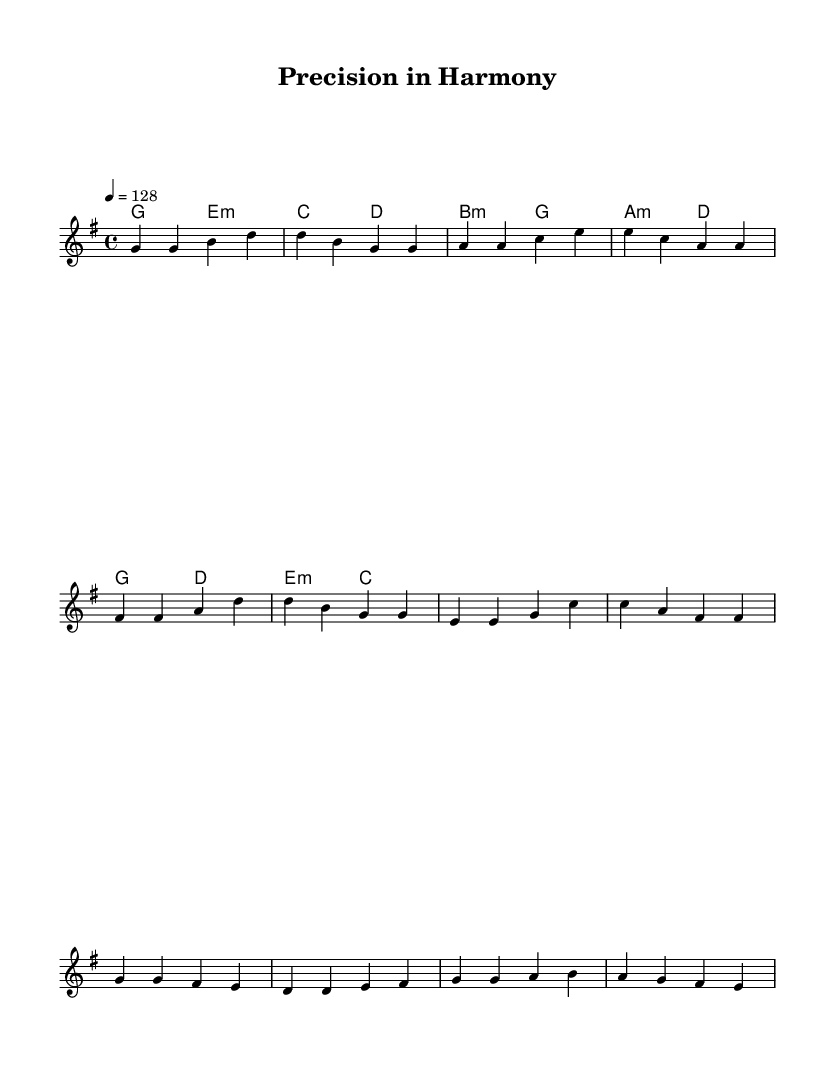What is the key signature of this music? The key signature is G major, indicated by one sharp (F#) in the key signature section at the beginning of the piece.
Answer: G major What is the time signature of this music? The time signature is 4/4, which is indicated at the beginning of the piece, showing that there are four beats in each measure.
Answer: 4/4 What is the tempo marking for this piece? The tempo marking is 128 beats per minute, showing how fast the music should be played, indicated by "4 = 128" at the start.
Answer: 128 What chords are used in the verse section? The chords in the verse are G major and E minor, indicated by the harmony above the melody for the verse section.
Answer: G major, E minor How many measures are in the chorus? There are four measures in the chorus, as counted from the melody section where each group of notes represents one measure.
Answer: 4 What musical elements emphasize craftsmanship in this piece? The song uses precise rhythms and harmonies that reflect attention to detail, emphasizing the craftsmanship theme through its structured composition and lyrical flow.
Answer: Precision, structure What type of musical genre is this sheet music representing? This music represents K-Pop, characterized by catchy melodies and upbeat rhythms that align with contemporary popular music trends.
Answer: K-Pop 